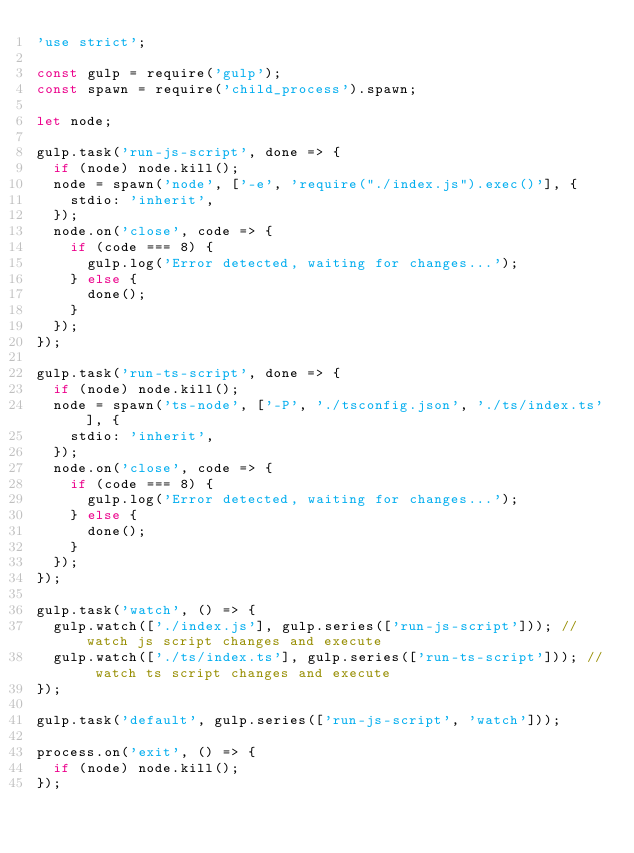<code> <loc_0><loc_0><loc_500><loc_500><_JavaScript_>'use strict';

const gulp = require('gulp');
const spawn = require('child_process').spawn;

let node;

gulp.task('run-js-script', done => {
  if (node) node.kill();
  node = spawn('node', ['-e', 'require("./index.js").exec()'], {
    stdio: 'inherit',
  });
  node.on('close', code => {
    if (code === 8) {
      gulp.log('Error detected, waiting for changes...');
    } else {
      done();
    }
  });
});

gulp.task('run-ts-script', done => {
  if (node) node.kill();
  node = spawn('ts-node', ['-P', './tsconfig.json', './ts/index.ts'], {
    stdio: 'inherit',
  });
  node.on('close', code => {
    if (code === 8) {
      gulp.log('Error detected, waiting for changes...');
    } else {
      done();
    }
  });
});

gulp.task('watch', () => {
  gulp.watch(['./index.js'], gulp.series(['run-js-script'])); // watch js script changes and execute
  gulp.watch(['./ts/index.ts'], gulp.series(['run-ts-script'])); // watch ts script changes and execute
});

gulp.task('default', gulp.series(['run-js-script', 'watch']));

process.on('exit', () => {
  if (node) node.kill();
});
</code> 